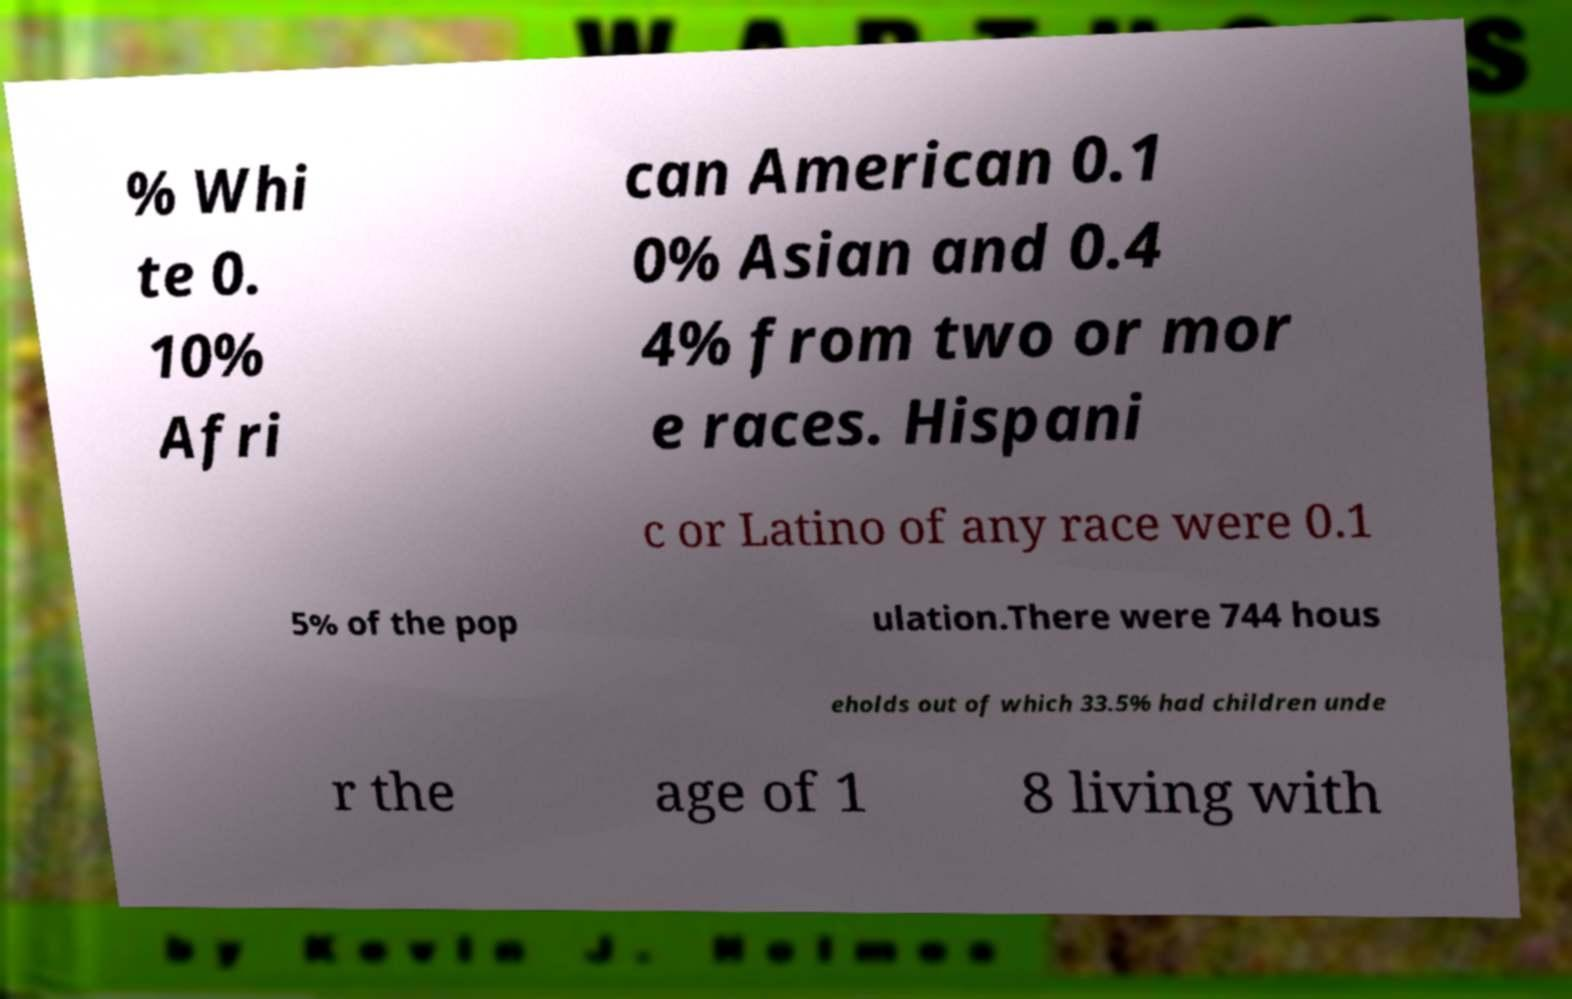Please read and relay the text visible in this image. What does it say? % Whi te 0. 10% Afri can American 0.1 0% Asian and 0.4 4% from two or mor e races. Hispani c or Latino of any race were 0.1 5% of the pop ulation.There were 744 hous eholds out of which 33.5% had children unde r the age of 1 8 living with 